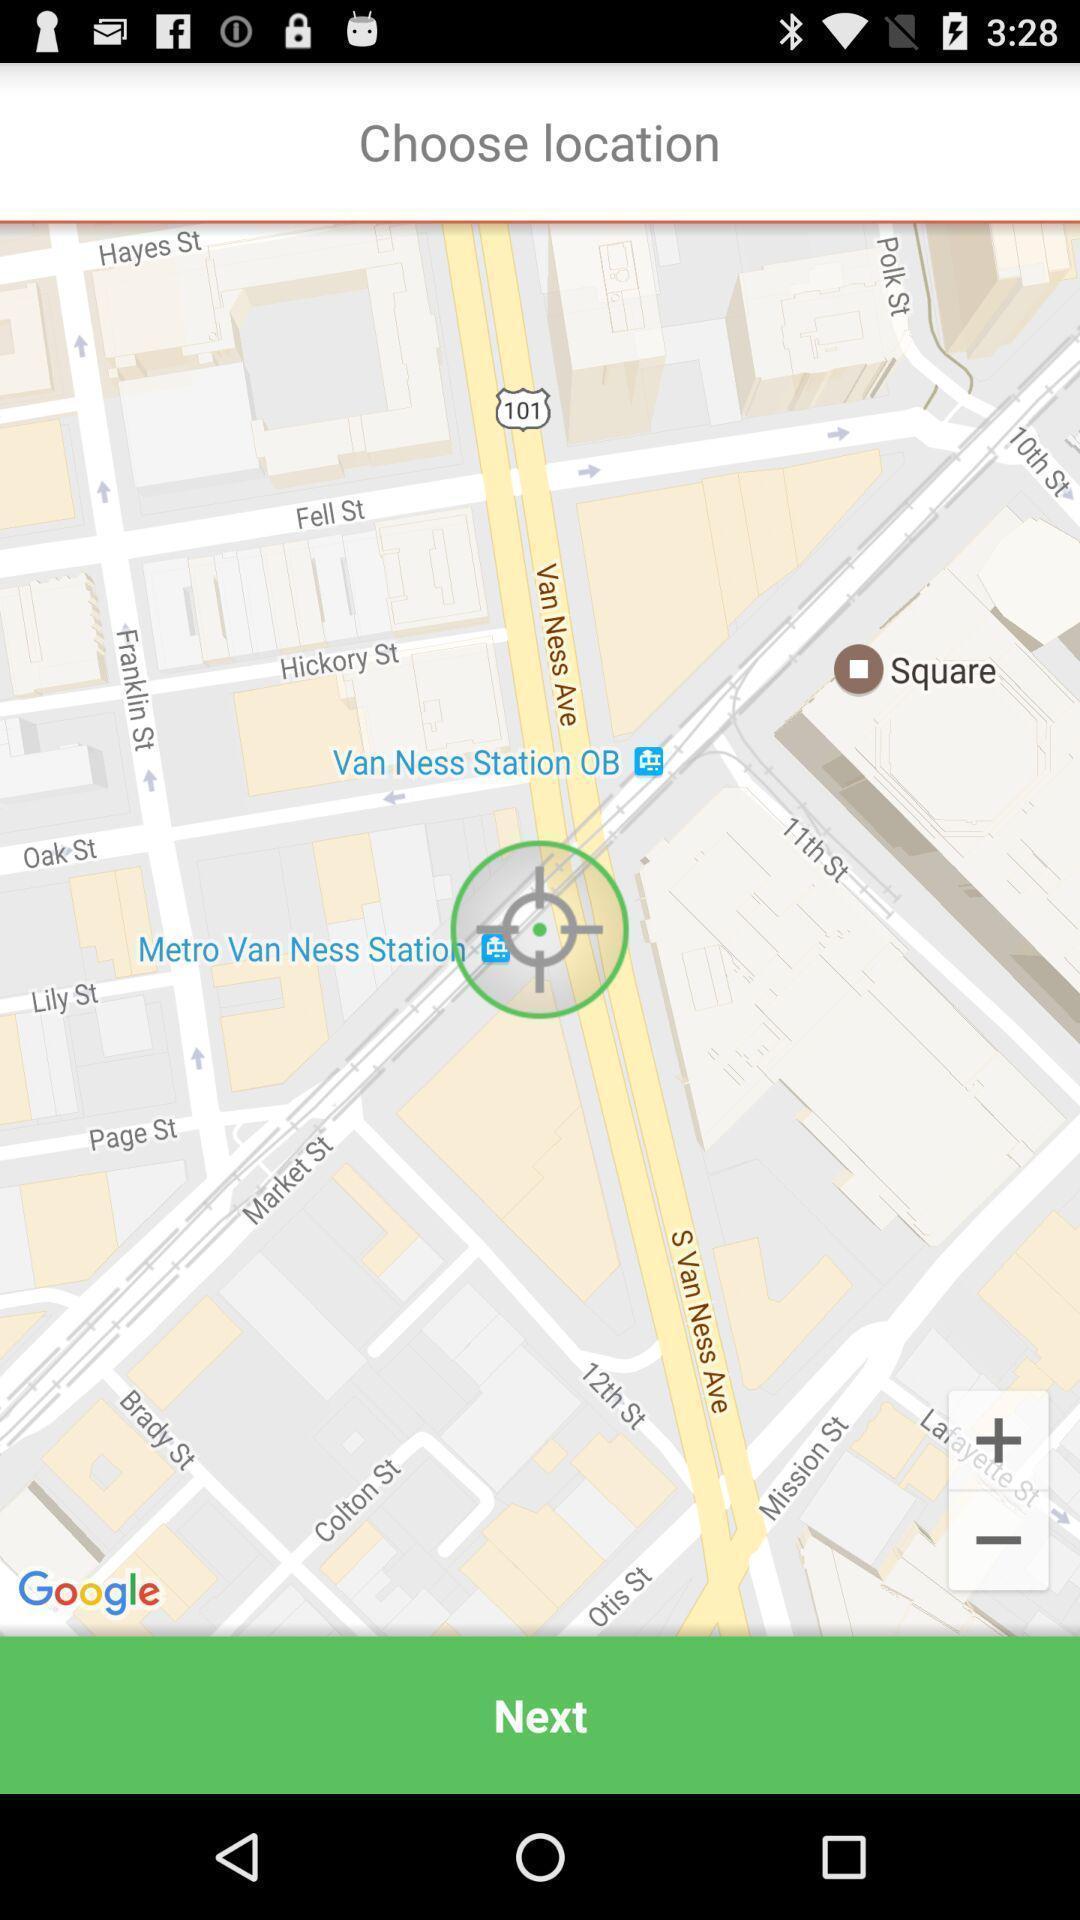Summarize the main components in this picture. Page showing to choose a location in maps. 